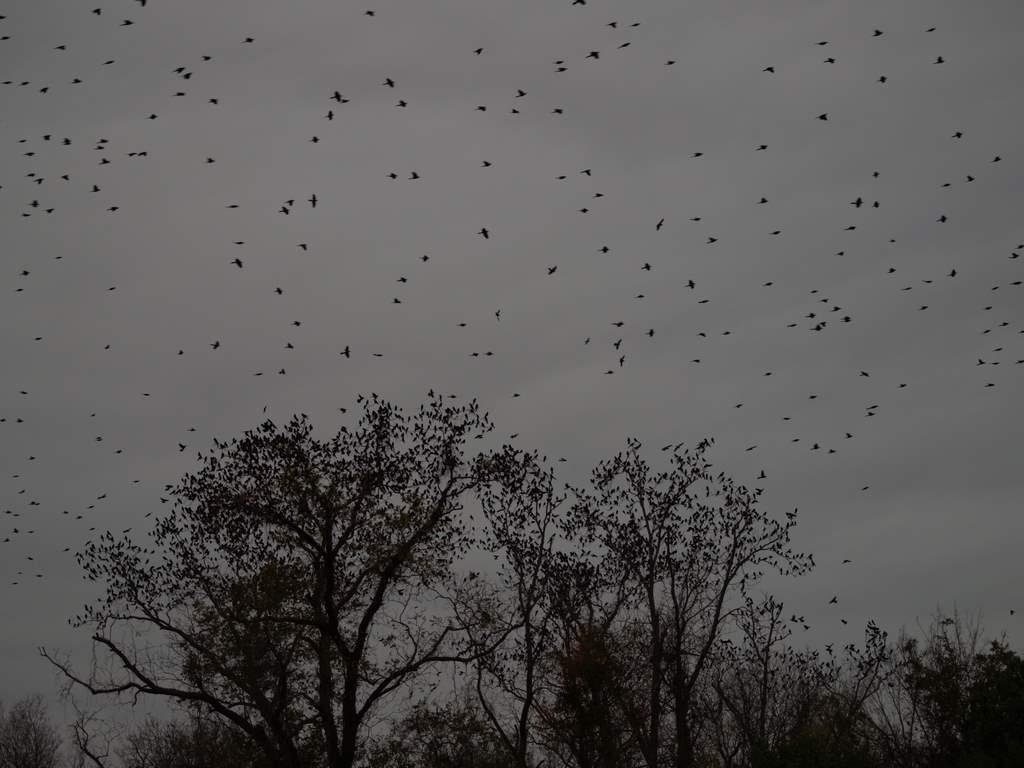What type of vegetation is present in the image? There are trees in the image. What is on the trees in the image? There are birds on the trees. What is visible at the top of the image? The sky is visible at the top of the image. What are the birds doing in the sky? There are birds flying in the sky. What type of notebook can be seen in the image? There is no notebook present in the image. Is the scene in the image taking place during winter? The provided facts do not mention any seasonal context, so it cannot be determined if the scene is taking place during winter. 